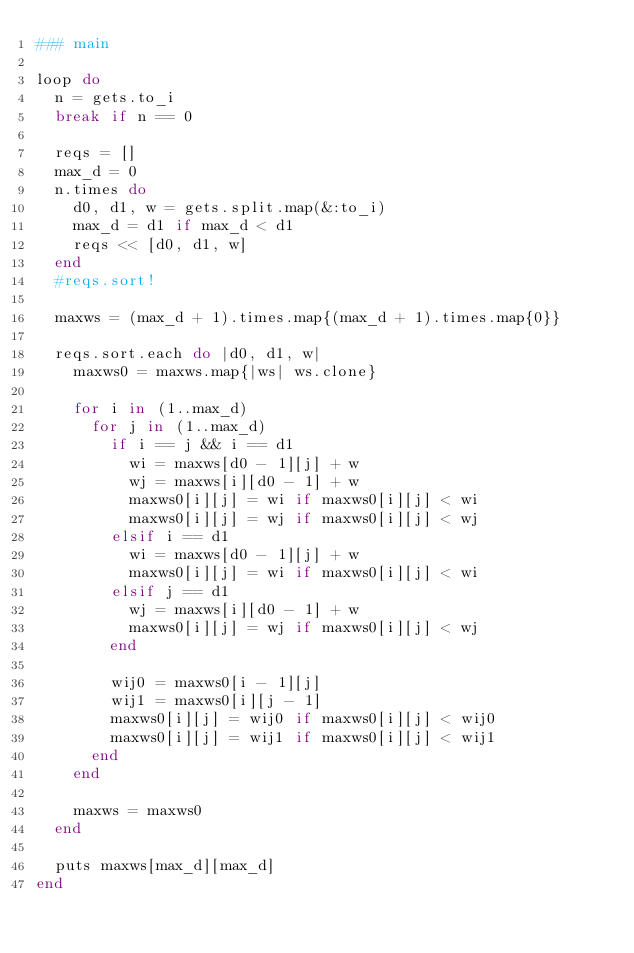<code> <loc_0><loc_0><loc_500><loc_500><_Ruby_>### main

loop do
  n = gets.to_i
  break if n == 0

  reqs = []
  max_d = 0
  n.times do
    d0, d1, w = gets.split.map(&:to_i)
    max_d = d1 if max_d < d1
    reqs << [d0, d1, w]
  end
  #reqs.sort!

  maxws = (max_d + 1).times.map{(max_d + 1).times.map{0}}

  reqs.sort.each do |d0, d1, w|
    maxws0 = maxws.map{|ws| ws.clone}

    for i in (1..max_d)
      for j in (1..max_d)
        if i == j && i == d1
          wi = maxws[d0 - 1][j] + w
          wj = maxws[i][d0 - 1] + w
          maxws0[i][j] = wi if maxws0[i][j] < wi
          maxws0[i][j] = wj if maxws0[i][j] < wj
        elsif i == d1
          wi = maxws[d0 - 1][j] + w
          maxws0[i][j] = wi if maxws0[i][j] < wi
        elsif j == d1
          wj = maxws[i][d0 - 1] + w
          maxws0[i][j] = wj if maxws0[i][j] < wj
        end

        wij0 = maxws0[i - 1][j]
        wij1 = maxws0[i][j - 1]
        maxws0[i][j] = wij0 if maxws0[i][j] < wij0
        maxws0[i][j] = wij1 if maxws0[i][j] < wij1
      end
    end

    maxws = maxws0
  end

  puts maxws[max_d][max_d]
end</code> 